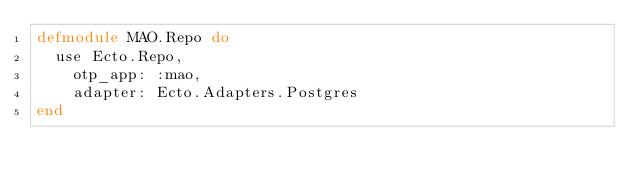Convert code to text. <code><loc_0><loc_0><loc_500><loc_500><_Elixir_>defmodule MAO.Repo do
  use Ecto.Repo,
    otp_app: :mao,
    adapter: Ecto.Adapters.Postgres
end
</code> 